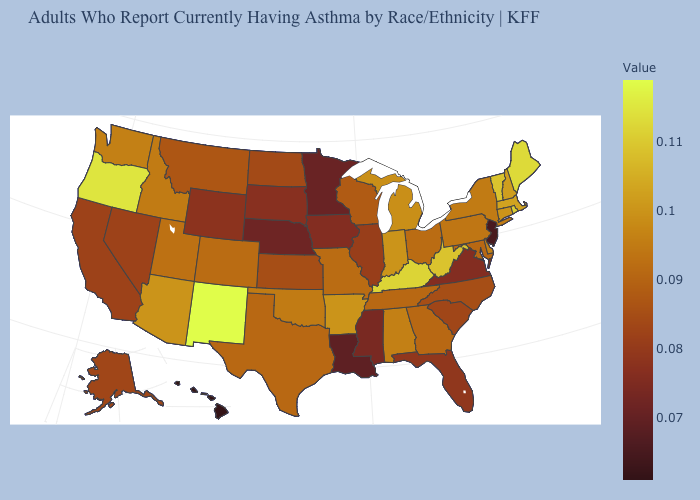Does the map have missing data?
Write a very short answer. No. Which states have the highest value in the USA?
Answer briefly. New Mexico. Does New Mexico have the highest value in the USA?
Short answer required. Yes. Does Hawaii have the lowest value in the West?
Short answer required. Yes. Does the map have missing data?
Give a very brief answer. No. Which states have the lowest value in the Northeast?
Answer briefly. New Jersey. 